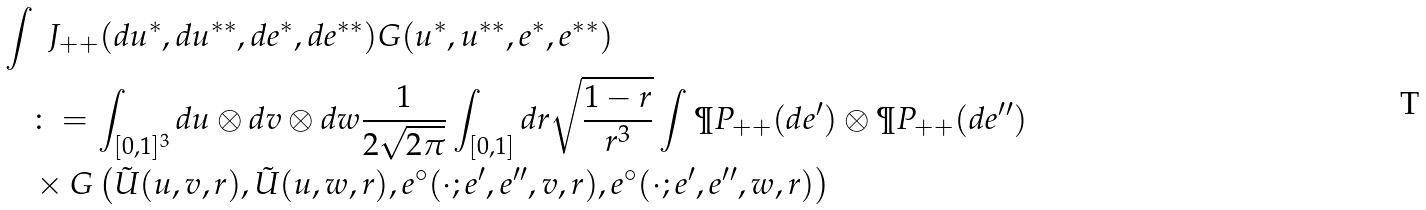<formula> <loc_0><loc_0><loc_500><loc_500>& \int \ J _ { + + } ( d u ^ { * } , d u ^ { * * } , d e ^ { * } , d e ^ { * * } ) G ( u ^ { * } , u ^ { * * } , e ^ { * } , e ^ { * * } ) \\ & \quad \colon = \int _ { [ 0 , 1 ] ^ { 3 } } d u \otimes d v \otimes d w \frac { 1 } { 2 \sqrt { 2 \pi } } \int _ { [ 0 , 1 ] } d r \sqrt { \frac { 1 - r } { r ^ { 3 } } } \int \P P _ { + + } ( d e ^ { \prime } ) \otimes \P P _ { + + } ( d e ^ { \prime \prime } ) \\ & \quad \times G \left ( \tilde { U } ( u , v , r ) , \tilde { U } ( u , w , r ) , e ^ { \circ } ( \cdot ; e ^ { \prime } , e ^ { \prime \prime } , v , r ) , e ^ { \circ } ( \cdot ; e ^ { \prime } , e ^ { \prime \prime } , w , r ) \right ) \\</formula> 